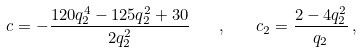<formula> <loc_0><loc_0><loc_500><loc_500>c = - \frac { 1 2 0 q _ { 2 } ^ { 4 } - 1 2 5 q _ { 2 } ^ { 2 } + 3 0 } { 2 q _ { 2 } ^ { 2 } } \quad , \quad c _ { 2 } = \frac { 2 - 4 q _ { 2 } ^ { 2 } } { q _ { 2 } } \, ,</formula> 